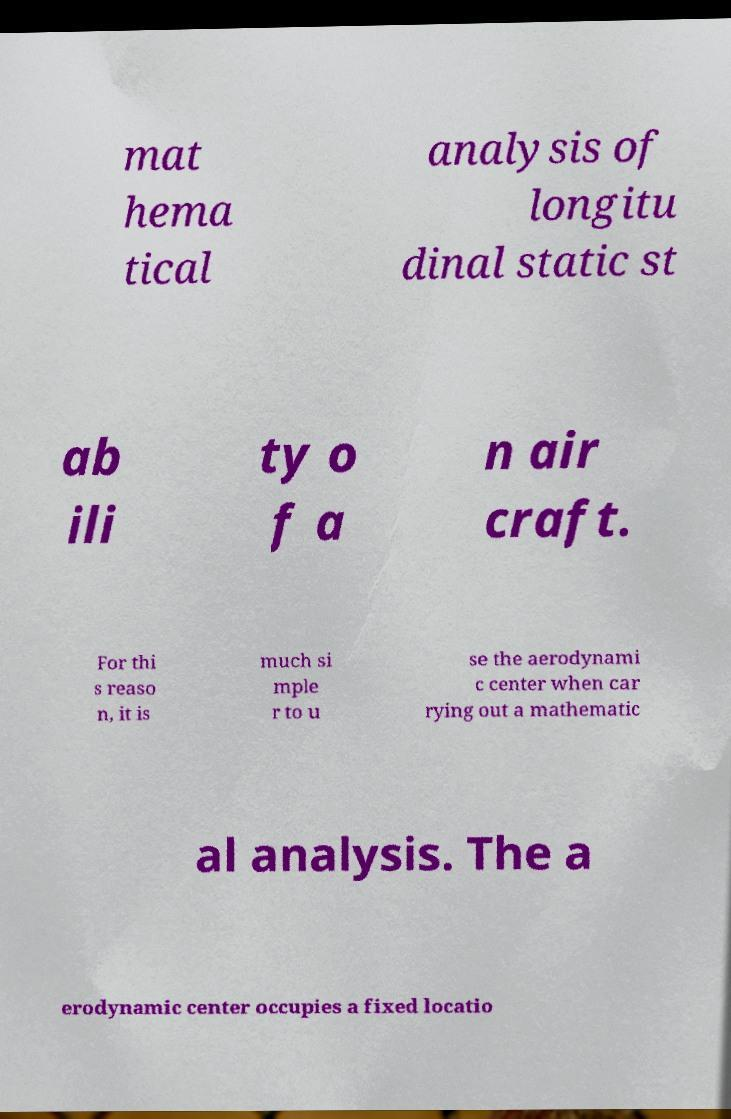What messages or text are displayed in this image? I need them in a readable, typed format. mat hema tical analysis of longitu dinal static st ab ili ty o f a n air craft. For thi s reaso n, it is much si mple r to u se the aerodynami c center when car rying out a mathematic al analysis. The a erodynamic center occupies a fixed locatio 